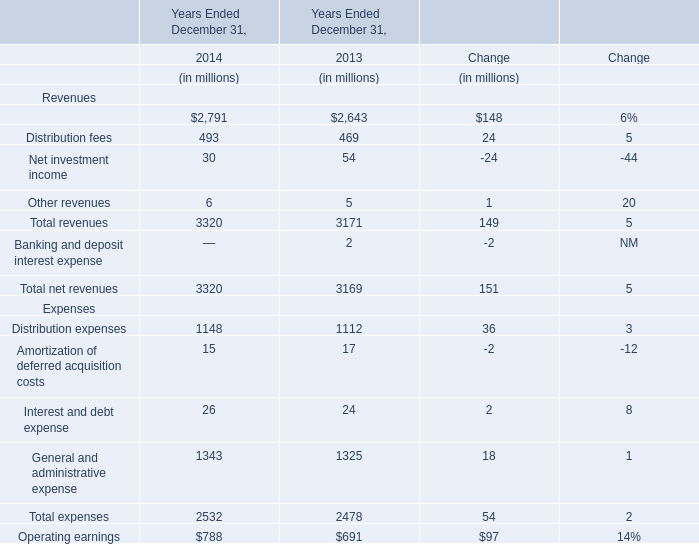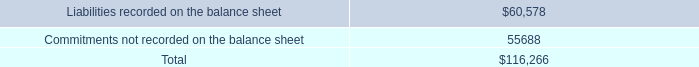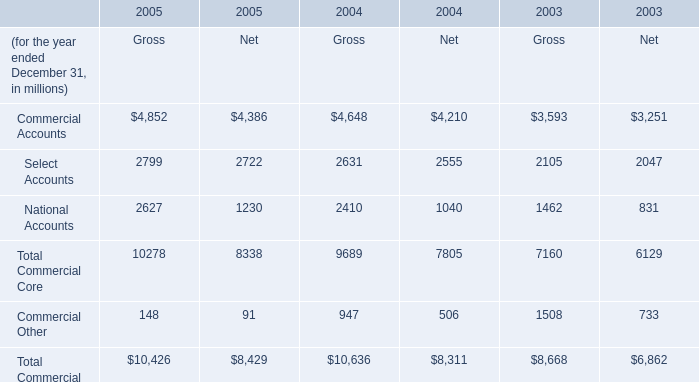What is the sum of National Accounts of 2004 Net, Liabilities recorded on the balance sheet, and Total Commercial Core of 2003 Gross ? 
Computations: ((1040.0 + 60578.0) + 7160.0)
Answer: 68778.0. 